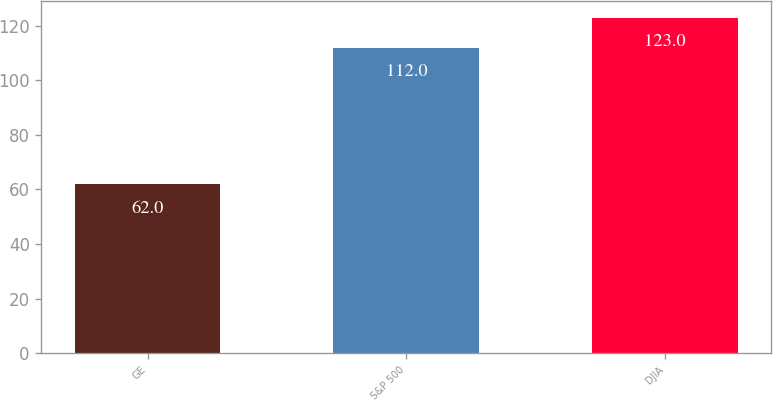Convert chart. <chart><loc_0><loc_0><loc_500><loc_500><bar_chart><fcel>GE<fcel>S&P 500<fcel>DJIA<nl><fcel>62<fcel>112<fcel>123<nl></chart> 